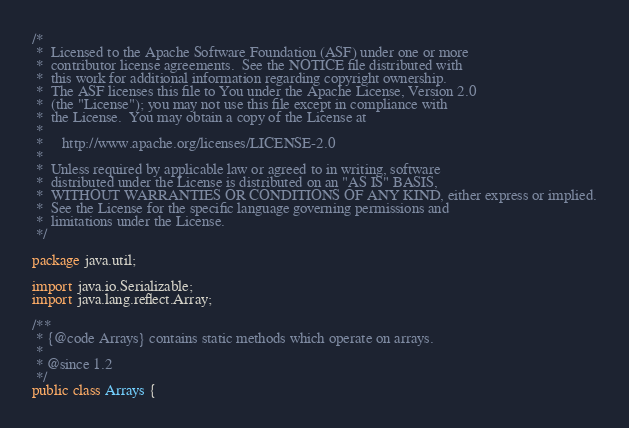Convert code to text. <code><loc_0><loc_0><loc_500><loc_500><_Java_>/*
 *  Licensed to the Apache Software Foundation (ASF) under one or more
 *  contributor license agreements.  See the NOTICE file distributed with
 *  this work for additional information regarding copyright ownership.
 *  The ASF licenses this file to You under the Apache License, Version 2.0
 *  (the "License"); you may not use this file except in compliance with
 *  the License.  You may obtain a copy of the License at
 *
 *     http://www.apache.org/licenses/LICENSE-2.0
 *
 *  Unless required by applicable law or agreed to in writing, software
 *  distributed under the License is distributed on an "AS IS" BASIS,
 *  WITHOUT WARRANTIES OR CONDITIONS OF ANY KIND, either express or implied.
 *  See the License for the specific language governing permissions and
 *  limitations under the License.
 */

package java.util;

import java.io.Serializable;
import java.lang.reflect.Array;

/**
 * {@code Arrays} contains static methods which operate on arrays.
 *
 * @since 1.2
 */
public class Arrays {</code> 